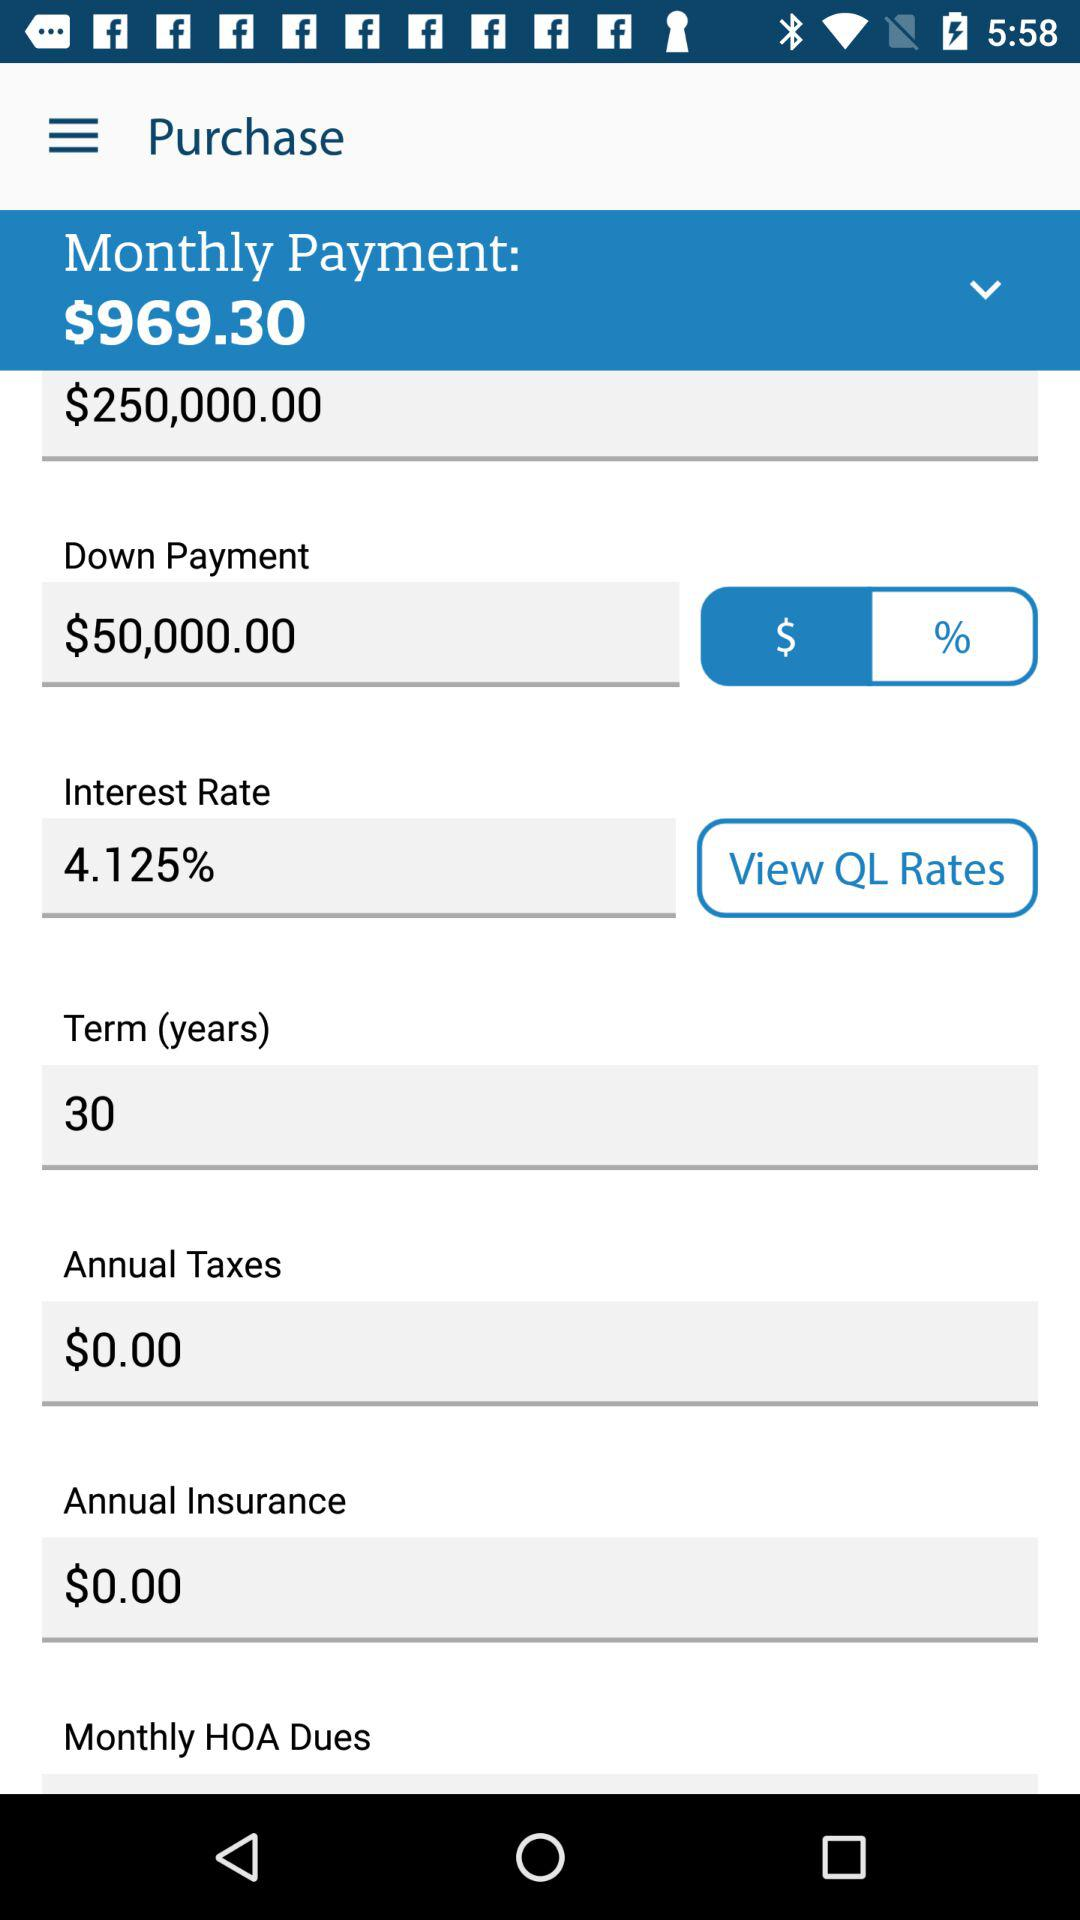What is the total amount of money that I will pay per month?
Answer the question using a single word or phrase. $969.30 